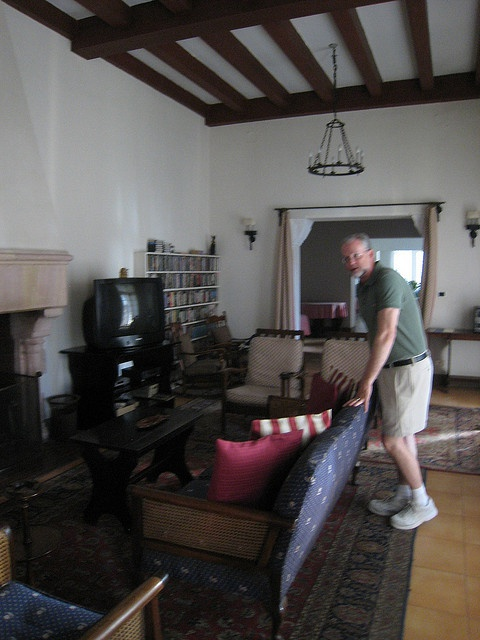Describe the objects in this image and their specific colors. I can see couch in gray, black, and maroon tones, people in gray, darkgray, black, and lightgray tones, book in gray, black, and darkgray tones, chair in gray, black, navy, and maroon tones, and tv in gray, black, and darkgray tones in this image. 